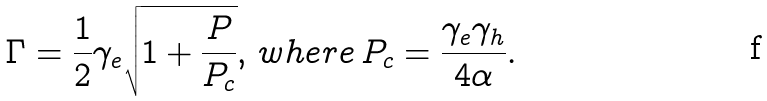<formula> <loc_0><loc_0><loc_500><loc_500>\Gamma = \frac { 1 } { 2 } \gamma _ { e } \sqrt { 1 + \frac { P } { P _ { c } } } , \, w h e r e \, P _ { c } = \frac { \gamma _ { e } \gamma _ { h } } { 4 \alpha } .</formula> 